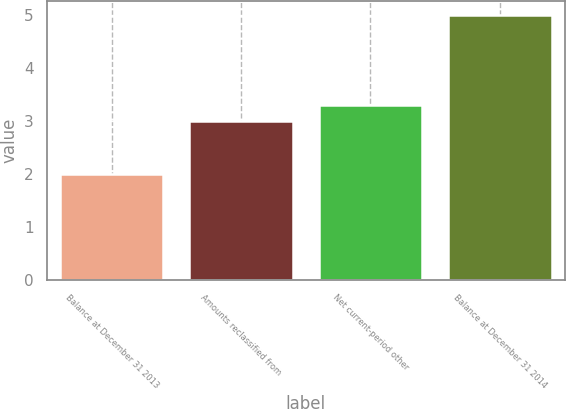Convert chart. <chart><loc_0><loc_0><loc_500><loc_500><bar_chart><fcel>Balance at December 31 2013<fcel>Amounts reclassified from<fcel>Net current-period other<fcel>Balance at December 31 2014<nl><fcel>2<fcel>3<fcel>3.3<fcel>5<nl></chart> 